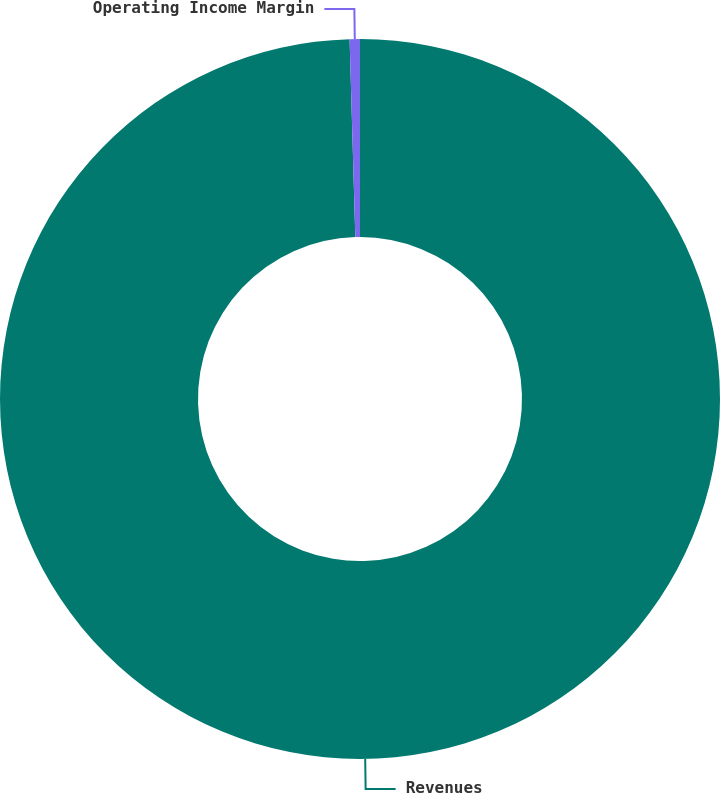Convert chart. <chart><loc_0><loc_0><loc_500><loc_500><pie_chart><fcel>Revenues<fcel>Operating Income Margin<nl><fcel>99.54%<fcel>0.46%<nl></chart> 